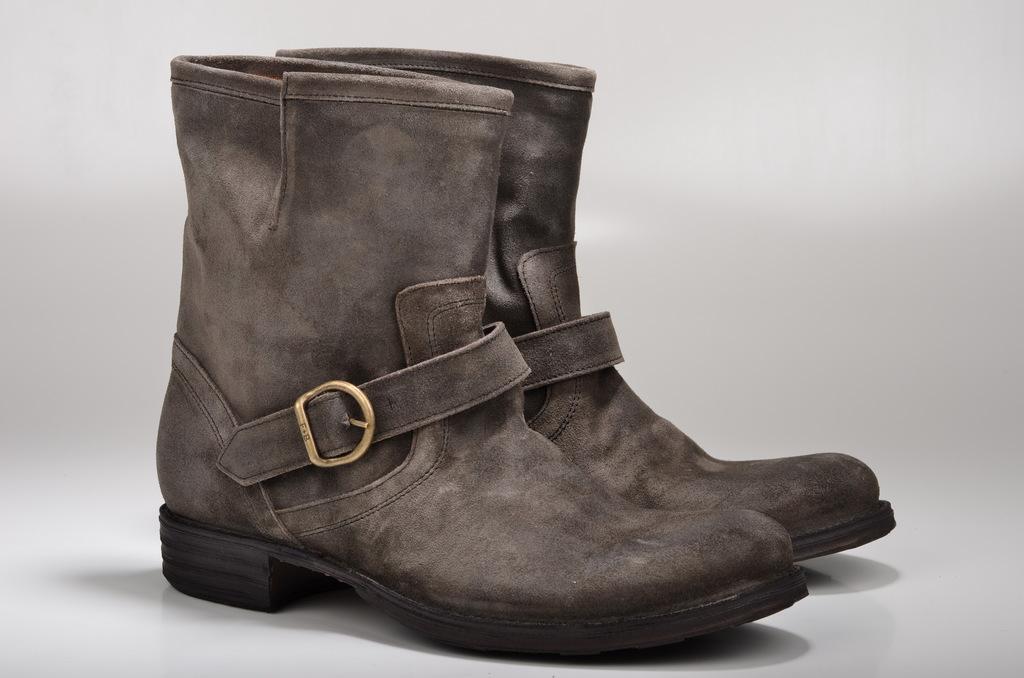In one or two sentences, can you explain what this image depicts? This is the picture of two boots to which there is a belt. 